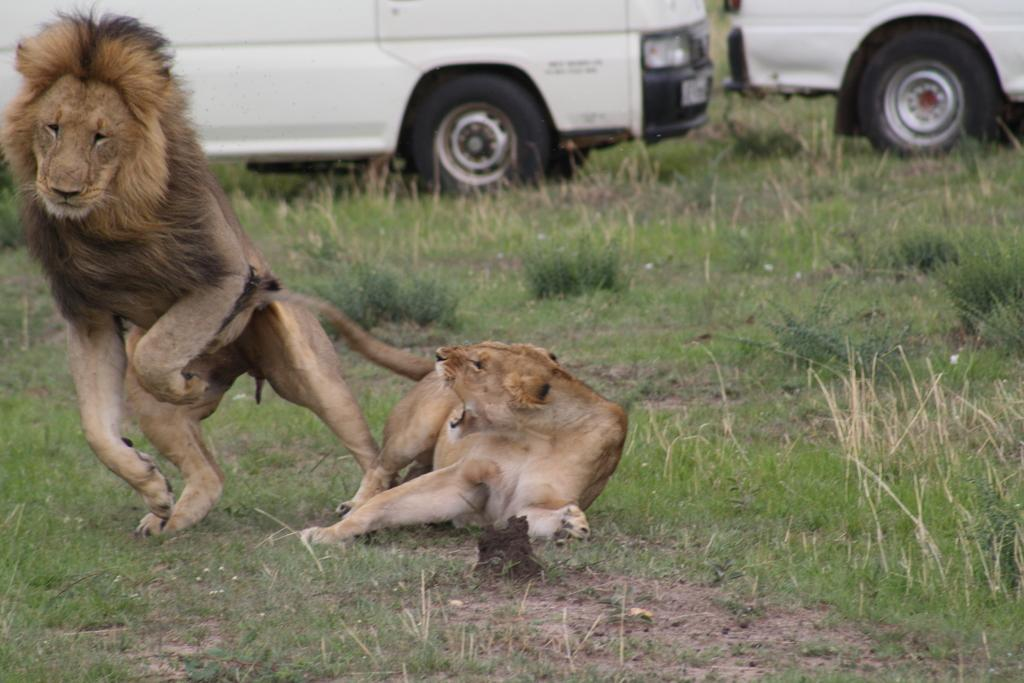What type of environment is depicted in the image? The image shows a grassland. What can be seen on the grassland? There are animals and vehicles on the grassland in the image. What type of thread is being used to support the pancake in the image? There is no thread or pancake present in the image. 